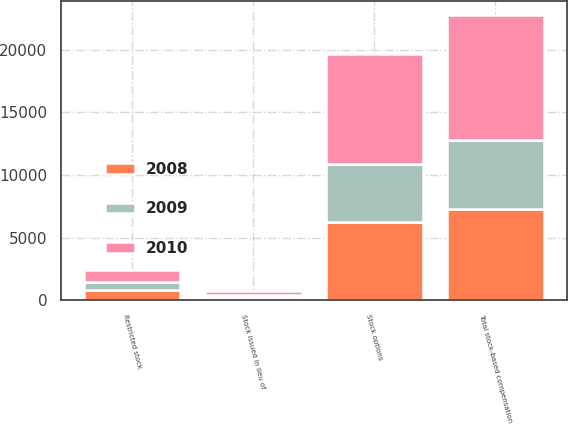<chart> <loc_0><loc_0><loc_500><loc_500><stacked_bar_chart><ecel><fcel>Stock options<fcel>Restricted stock<fcel>Stock issued in lieu of<fcel>Total stock-based compensation<nl><fcel>2010<fcel>8771<fcel>913<fcel>290<fcel>9974<nl><fcel>2008<fcel>6219<fcel>774<fcel>290<fcel>7283<nl><fcel>2009<fcel>4671<fcel>705<fcel>122<fcel>5498<nl></chart> 